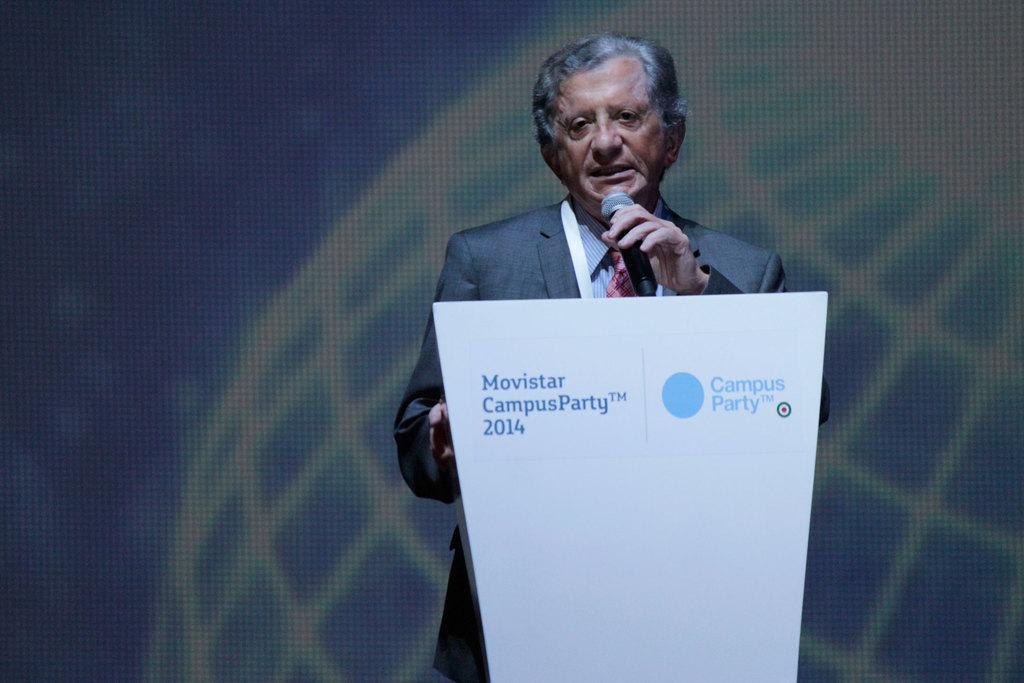What is the person near in the image? There is a person standing near the podium in the image. What is the person doing near the podium? The person is speaking into a microphone. What can be seen behind the person? There is a digital screen behind the person. What is written or displayed on the podium? There is some text on the podium. What type of ship can be seen sailing on the sidewalk in the image? There is no ship or sidewalk present in the image; it features a person standing near a podium with a digital screen and text on the podium. 